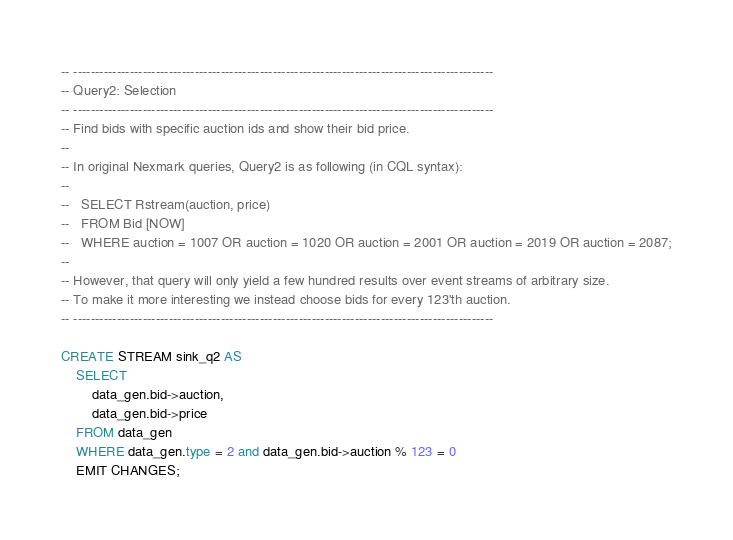<code> <loc_0><loc_0><loc_500><loc_500><_SQL_>-- -------------------------------------------------------------------------------------------------
-- Query2: Selection
-- -------------------------------------------------------------------------------------------------
-- Find bids with specific auction ids and show their bid price.
--
-- In original Nexmark queries, Query2 is as following (in CQL syntax):
--
--   SELECT Rstream(auction, price)
--   FROM Bid [NOW]
--   WHERE auction = 1007 OR auction = 1020 OR auction = 2001 OR auction = 2019 OR auction = 2087;
--
-- However, that query will only yield a few hundred results over event streams of arbitrary size.
-- To make it more interesting we instead choose bids for every 123'th auction.
-- -------------------------------------------------------------------------------------------------

CREATE STREAM sink_q2 AS
    SELECT 
        data_gen.bid->auction, 
        data_gen.bid->price
    FROM data_gen 
    WHERE data_gen.type = 2 and data_gen.bid->auction % 123 = 0
    EMIT CHANGES;</code> 